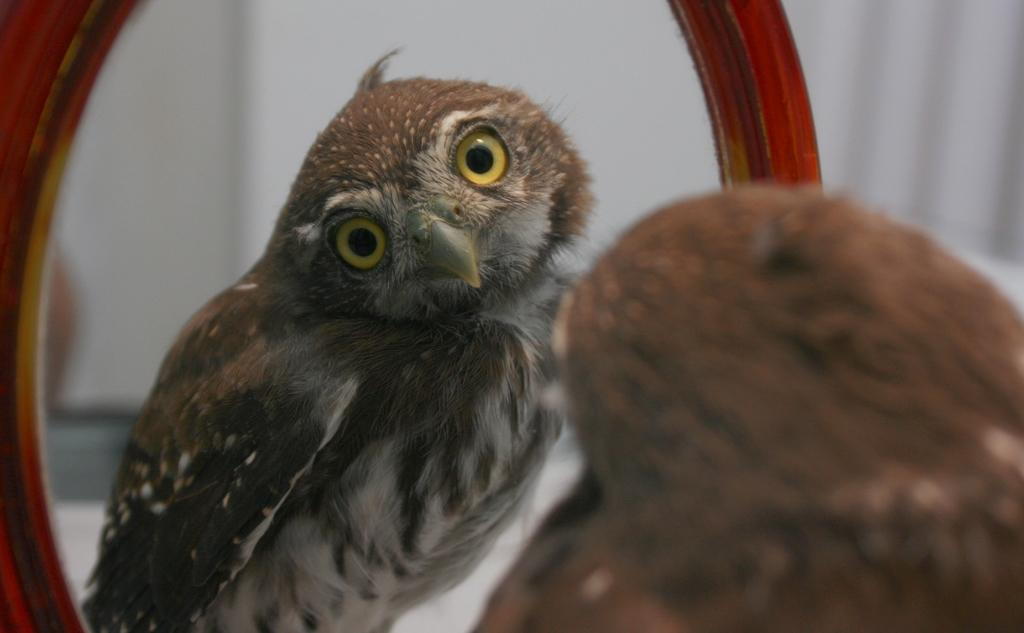What type of animal is present in the image? There is a bird in the image. What object is also visible in the image? There is a mirror in the image. Can you describe what is visible in the mirror? The bird's reflection is visible in the mirror. What type of map is the minister holding in the image? There is no map or minister present in the image; it features a bird and a mirror. 